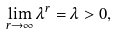<formula> <loc_0><loc_0><loc_500><loc_500>\lim _ { r \to \infty } \lambda ^ { r } = \lambda > 0 ,</formula> 